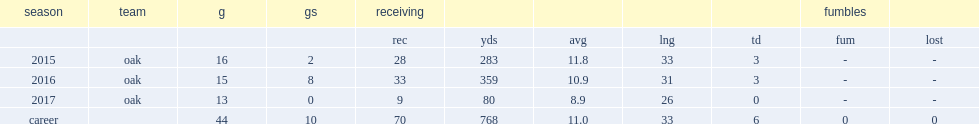How many receiving yards did walford get in 2016? 359.0. 